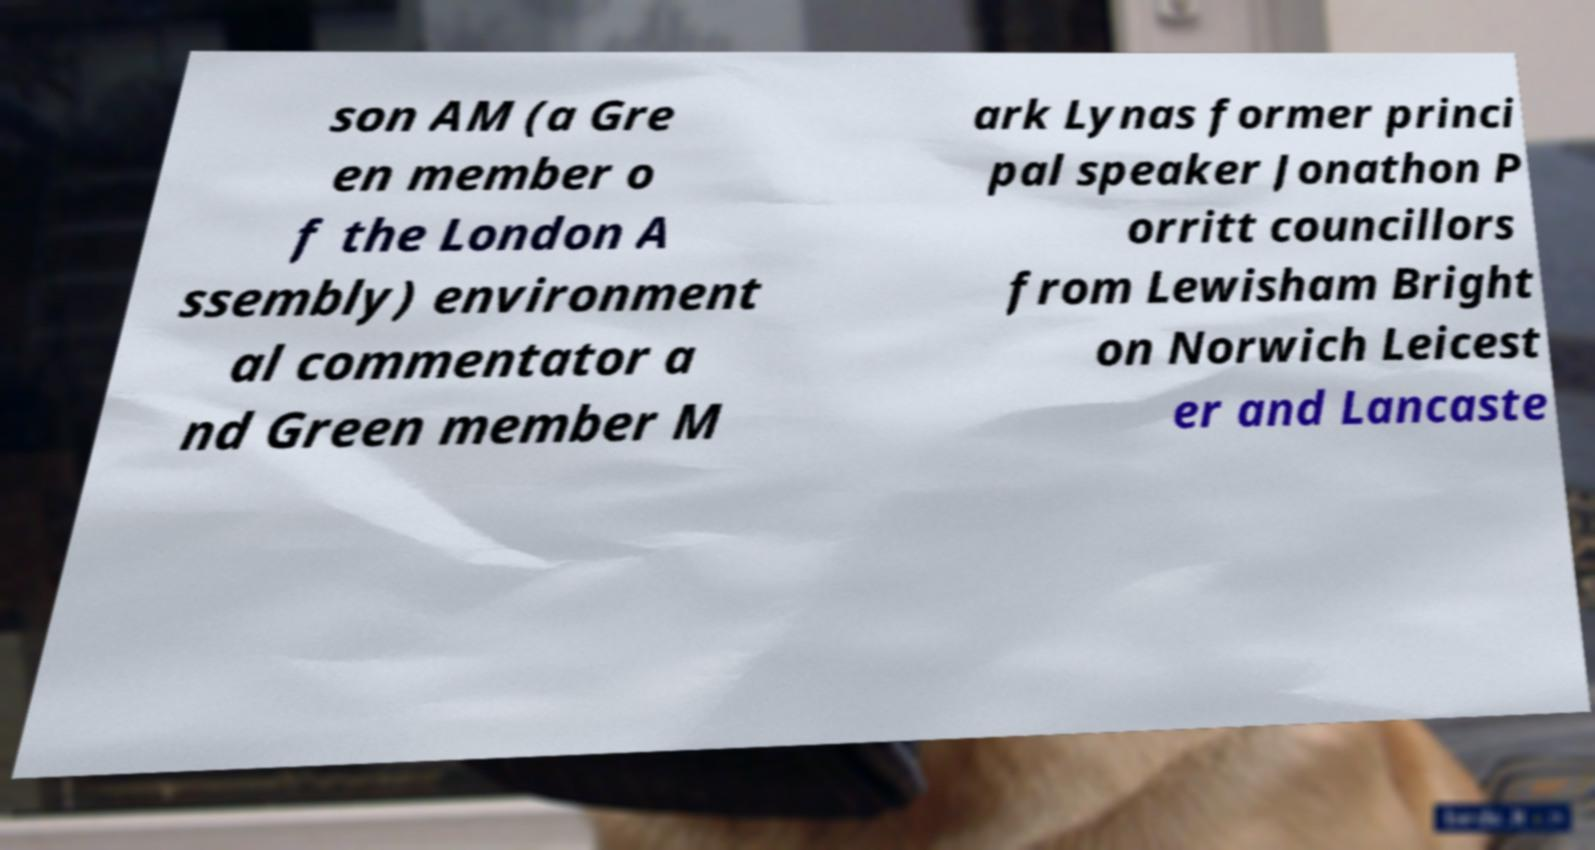Please identify and transcribe the text found in this image. son AM (a Gre en member o f the London A ssembly) environment al commentator a nd Green member M ark Lynas former princi pal speaker Jonathon P orritt councillors from Lewisham Bright on Norwich Leicest er and Lancaste 